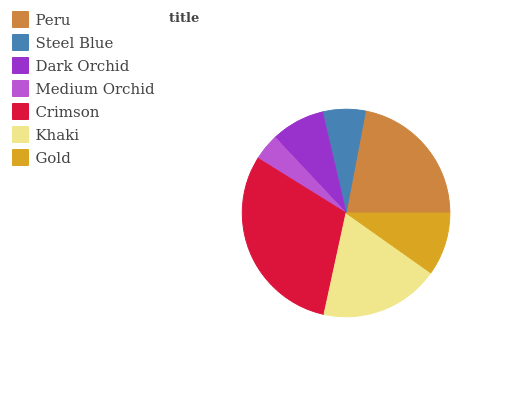Is Medium Orchid the minimum?
Answer yes or no. Yes. Is Crimson the maximum?
Answer yes or no. Yes. Is Steel Blue the minimum?
Answer yes or no. No. Is Steel Blue the maximum?
Answer yes or no. No. Is Peru greater than Steel Blue?
Answer yes or no. Yes. Is Steel Blue less than Peru?
Answer yes or no. Yes. Is Steel Blue greater than Peru?
Answer yes or no. No. Is Peru less than Steel Blue?
Answer yes or no. No. Is Gold the high median?
Answer yes or no. Yes. Is Gold the low median?
Answer yes or no. Yes. Is Khaki the high median?
Answer yes or no. No. Is Dark Orchid the low median?
Answer yes or no. No. 